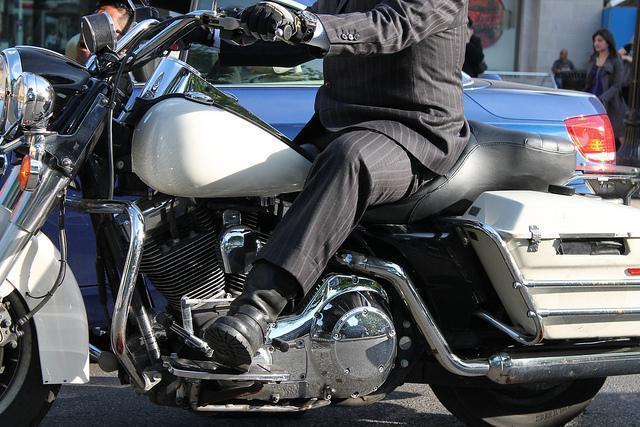Why is the rider wearing gloves?
Select the accurate answer and provide explanation: 'Answer: answer
Rationale: rationale.'
Options: Fashion, warmth, health, grip. Answer: grip.
Rationale: The gloves are heavy and appear to be insulated, indicating they are being worn to protect against the cold. 